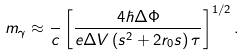<formula> <loc_0><loc_0><loc_500><loc_500>m _ { \gamma } \approx \frac { } { c } \left [ \frac { 4 \hbar { \Delta } \Phi } { e \Delta V \left ( s ^ { 2 } + 2 r _ { 0 } s \right ) \tau } \right ] ^ { 1 / 2 } .</formula> 